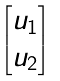<formula> <loc_0><loc_0><loc_500><loc_500>\begin{bmatrix} u _ { 1 } \\ u _ { 2 } \end{bmatrix}</formula> 